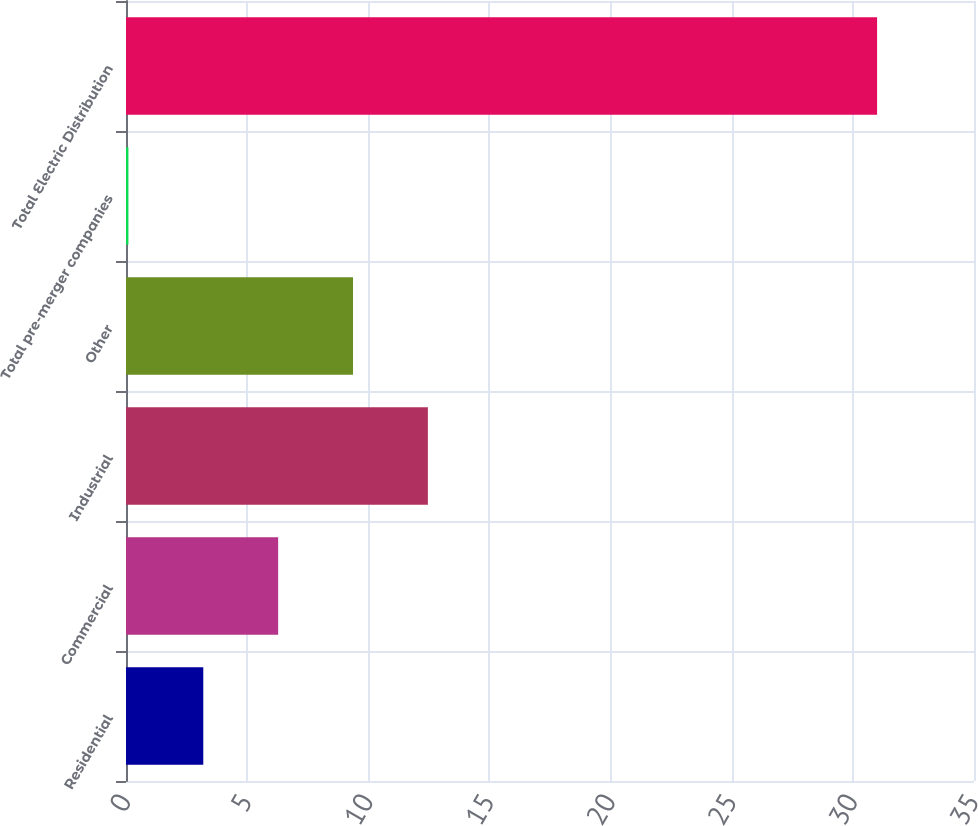<chart> <loc_0><loc_0><loc_500><loc_500><bar_chart><fcel>Residential<fcel>Commercial<fcel>Industrial<fcel>Other<fcel>Total pre-merger companies<fcel>Total Electric Distribution<nl><fcel>3.19<fcel>6.28<fcel>12.46<fcel>9.37<fcel>0.1<fcel>31<nl></chart> 